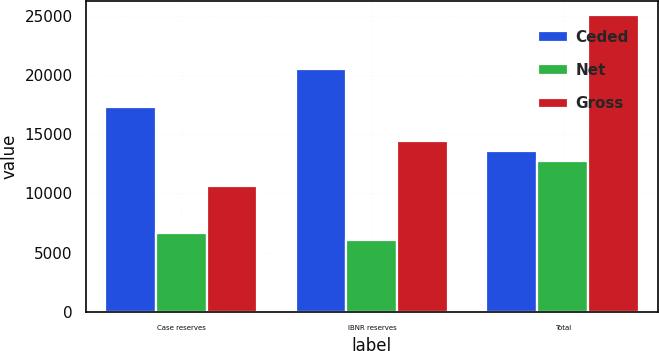Convert chart. <chart><loc_0><loc_0><loc_500><loc_500><stacked_bar_chart><ecel><fcel>Case reserves<fcel>IBNR reserves<fcel>Total<nl><fcel>Ceded<fcel>17307<fcel>20476<fcel>13570<nl><fcel>Net<fcel>6664<fcel>6081<fcel>12745<nl><fcel>Gross<fcel>10643<fcel>14395<fcel>25038<nl></chart> 